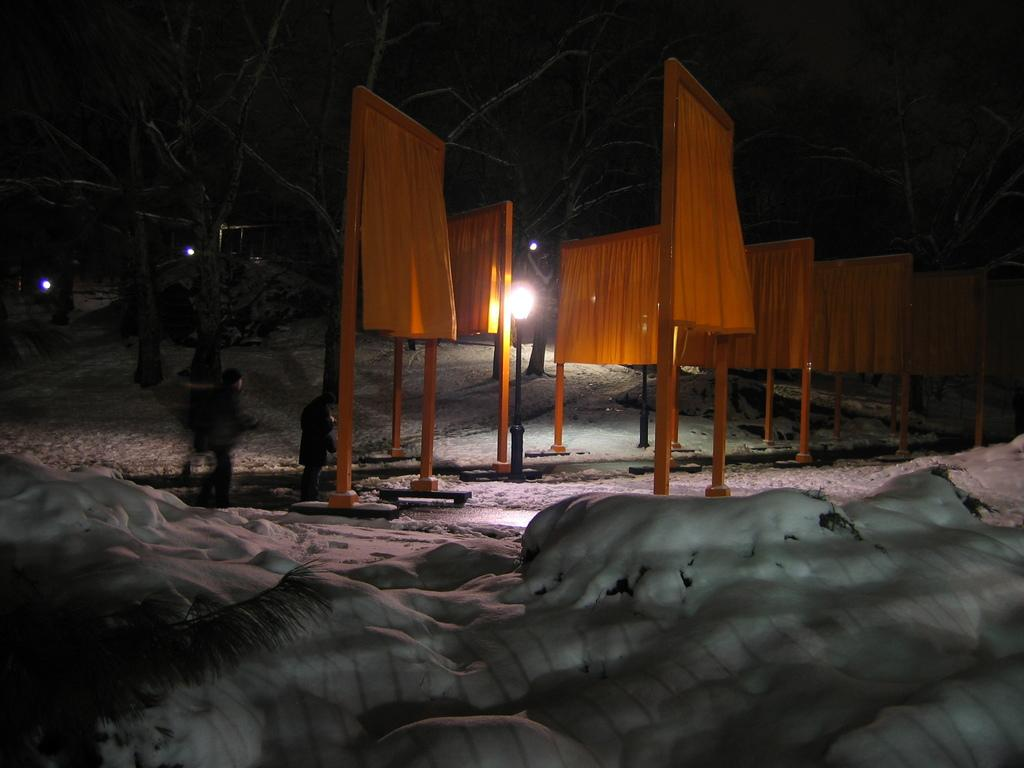What color are the clothes hanging in the picture? The clothes hanging in the picture are yellow. What is the condition of the land in the picture? The land in the picture has snow on it. How would you describe the background of the image? The background of the image is dark. What is the weight of the jellyfish swimming in the picture? There are no jellyfish present in the image; it features yellow clothes hanging and snow on the land. 